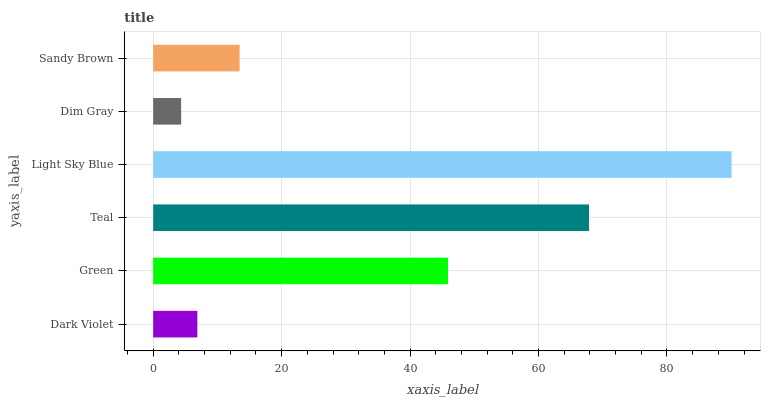Is Dim Gray the minimum?
Answer yes or no. Yes. Is Light Sky Blue the maximum?
Answer yes or no. Yes. Is Green the minimum?
Answer yes or no. No. Is Green the maximum?
Answer yes or no. No. Is Green greater than Dark Violet?
Answer yes or no. Yes. Is Dark Violet less than Green?
Answer yes or no. Yes. Is Dark Violet greater than Green?
Answer yes or no. No. Is Green less than Dark Violet?
Answer yes or no. No. Is Green the high median?
Answer yes or no. Yes. Is Sandy Brown the low median?
Answer yes or no. Yes. Is Sandy Brown the high median?
Answer yes or no. No. Is Dark Violet the low median?
Answer yes or no. No. 